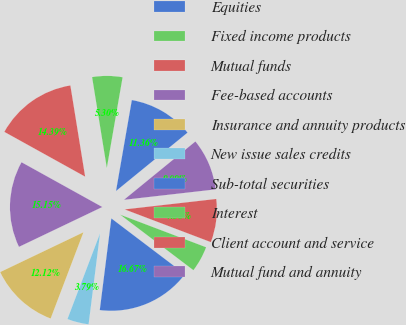Convert chart to OTSL. <chart><loc_0><loc_0><loc_500><loc_500><pie_chart><fcel>Equities<fcel>Fixed income products<fcel>Mutual funds<fcel>Fee-based accounts<fcel>Insurance and annuity products<fcel>New issue sales credits<fcel>Sub-total securities<fcel>Interest<fcel>Client account and service<fcel>Mutual fund and annuity<nl><fcel>11.36%<fcel>5.3%<fcel>14.39%<fcel>15.15%<fcel>12.12%<fcel>3.79%<fcel>16.67%<fcel>4.55%<fcel>7.58%<fcel>9.09%<nl></chart> 